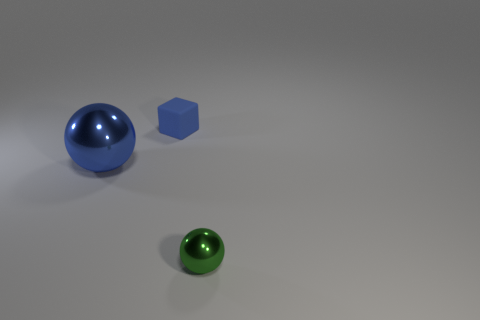Is there a red cube that has the same material as the big object?
Ensure brevity in your answer.  No. Are the blue sphere that is to the left of the small blue rubber block and the small cube made of the same material?
Ensure brevity in your answer.  No. How big is the object that is both in front of the rubber thing and right of the large blue ball?
Offer a very short reply. Small. What color is the tiny metal sphere?
Your answer should be very brief. Green. How many balls are there?
Give a very brief answer. 2. How many blocks have the same color as the large ball?
Give a very brief answer. 1. Do the shiny thing behind the small green sphere and the small thing in front of the blue matte cube have the same shape?
Your answer should be very brief. Yes. What is the color of the small thing on the left side of the ball right of the object behind the blue shiny sphere?
Your answer should be compact. Blue. The small block that is behind the small green metallic sphere is what color?
Make the answer very short. Blue. The matte cube that is the same size as the green metal ball is what color?
Your answer should be compact. Blue. 